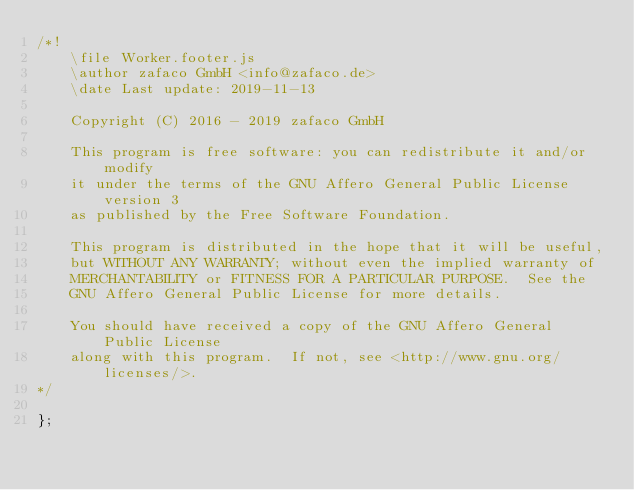<code> <loc_0><loc_0><loc_500><loc_500><_JavaScript_>/*!
    \file Worker.footer.js
    \author zafaco GmbH <info@zafaco.de>
    \date Last update: 2019-11-13

    Copyright (C) 2016 - 2019 zafaco GmbH

    This program is free software: you can redistribute it and/or modify
    it under the terms of the GNU Affero General Public License version 3 
    as published by the Free Software Foundation.

    This program is distributed in the hope that it will be useful,
    but WITHOUT ANY WARRANTY; without even the implied warranty of
    MERCHANTABILITY or FITNESS FOR A PARTICULAR PURPOSE.  See the
    GNU Affero General Public License for more details.

    You should have received a copy of the GNU Affero General Public License
    along with this program.  If not, see <http://www.gnu.org/licenses/>.
*/

};</code> 